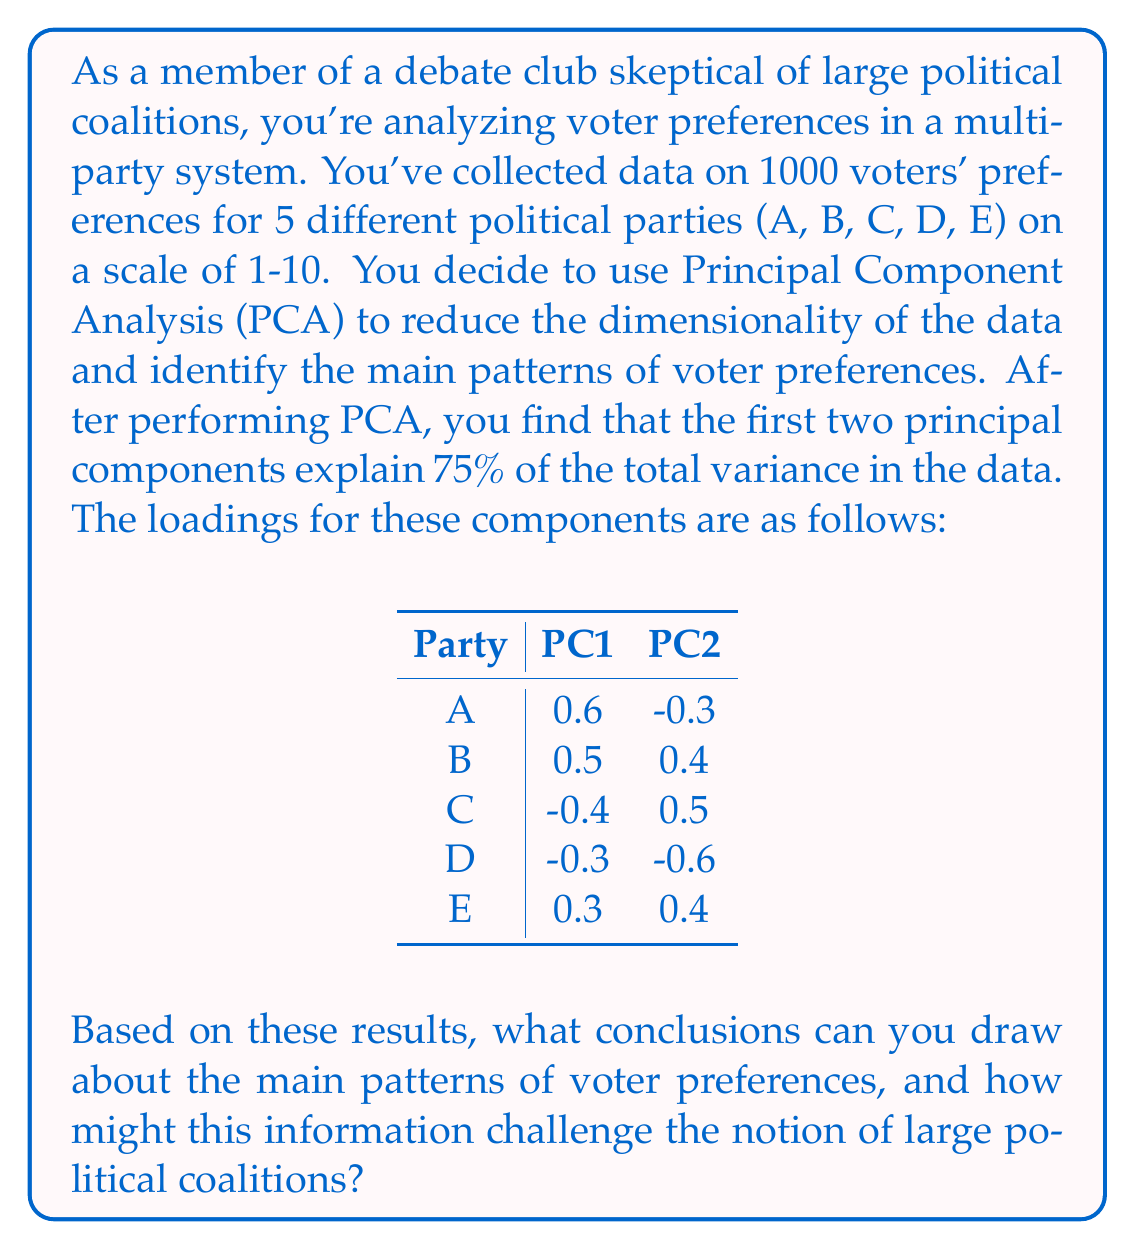Teach me how to tackle this problem. To interpret the results of the PCA and draw conclusions about voter preference patterns, we need to analyze the loadings of each principal component:

1. Interpreting PC1 (First Principal Component):
   - Parties A and B have strong positive loadings (0.6 and 0.5)
   - Parties C and D have moderate negative loadings (-0.4 and -0.3)
   - Party E has a weak positive loading (0.3)

   This suggests that PC1 represents a spectrum from preferences for parties C and D on one end to preferences for parties A and B on the other end.

2. Interpreting PC2 (Second Principal Component):
   - Parties B, C, and E have moderate positive loadings (0.4, 0.5, and 0.4)
   - Party D has a strong negative loading (-0.6)
   - Party A has a weak negative loading (-0.3)

   PC2 seems to contrast preferences for party D against preferences for parties B, C, and E.

3. Challenging large political coalitions:
   - The fact that two principal components explain 75% of the variance suggests that voter preferences are more complex than a simple left-right spectrum.
   - The loadings show that parties traditionally considered allies (e.g., A and B) may not always align in voter preferences.
   - Some unexpected relationships emerge, such as parties C and E having similar loadings on PC2 despite potentially different ideologies.

4. Main patterns of voter preferences:
   - There appears to be a primary divide between supporters of A/B and C/D (PC1).
   - A secondary pattern (PC2) distinguishes D from B/C/E, suggesting a more nuanced political landscape.
   - Party E seems to occupy a unique position, with weak to moderate positive loadings on both components.

These results challenge the notion of large political coalitions by revealing complex, multidimensional patterns in voter preferences that don't necessarily align with traditional political alliances. This analysis suggests that voters may have more nuanced views that cross traditional party lines, making large, stable coalitions potentially less representative of actual voter preferences.
Answer: The main patterns of voter preferences reveal a complex political landscape where:
1. The primary divide is between supporters of parties A/B and C/D.
2. A secondary pattern distinguishes party D from B/C/E.
3. Party E occupies a unique position with moderate appeal across different voter groups.

These patterns challenge large political coalitions by showing that voter preferences are multidimensional and don't always align with traditional party alliances, suggesting that such coalitions may not accurately represent the nuanced views of the electorate. 